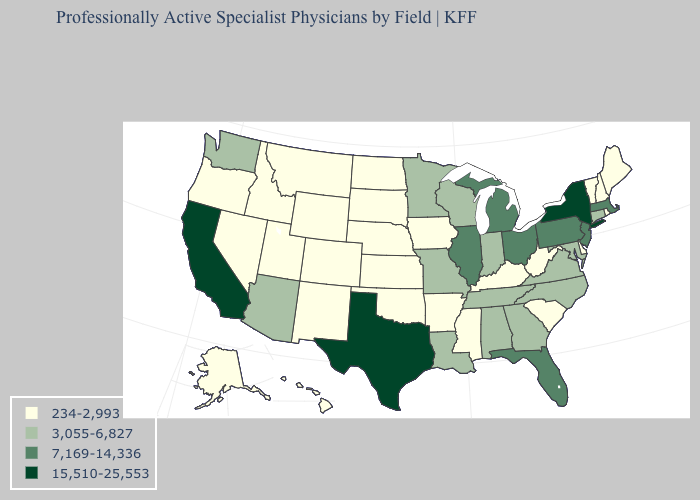What is the value of South Carolina?
Keep it brief. 234-2,993. What is the highest value in the USA?
Quick response, please. 15,510-25,553. What is the value of New Mexico?
Concise answer only. 234-2,993. Does Montana have the lowest value in the West?
Write a very short answer. Yes. What is the highest value in the South ?
Keep it brief. 15,510-25,553. Does Virginia have the same value as Kentucky?
Quick response, please. No. Is the legend a continuous bar?
Concise answer only. No. What is the lowest value in the West?
Short answer required. 234-2,993. Name the states that have a value in the range 3,055-6,827?
Give a very brief answer. Alabama, Arizona, Connecticut, Georgia, Indiana, Louisiana, Maryland, Minnesota, Missouri, North Carolina, Tennessee, Virginia, Washington, Wisconsin. What is the value of Nebraska?
Keep it brief. 234-2,993. What is the value of Washington?
Give a very brief answer. 3,055-6,827. Name the states that have a value in the range 7,169-14,336?
Give a very brief answer. Florida, Illinois, Massachusetts, Michigan, New Jersey, Ohio, Pennsylvania. Name the states that have a value in the range 234-2,993?
Write a very short answer. Alaska, Arkansas, Colorado, Delaware, Hawaii, Idaho, Iowa, Kansas, Kentucky, Maine, Mississippi, Montana, Nebraska, Nevada, New Hampshire, New Mexico, North Dakota, Oklahoma, Oregon, Rhode Island, South Carolina, South Dakota, Utah, Vermont, West Virginia, Wyoming. How many symbols are there in the legend?
Concise answer only. 4. Among the states that border Pennsylvania , does West Virginia have the lowest value?
Answer briefly. Yes. 